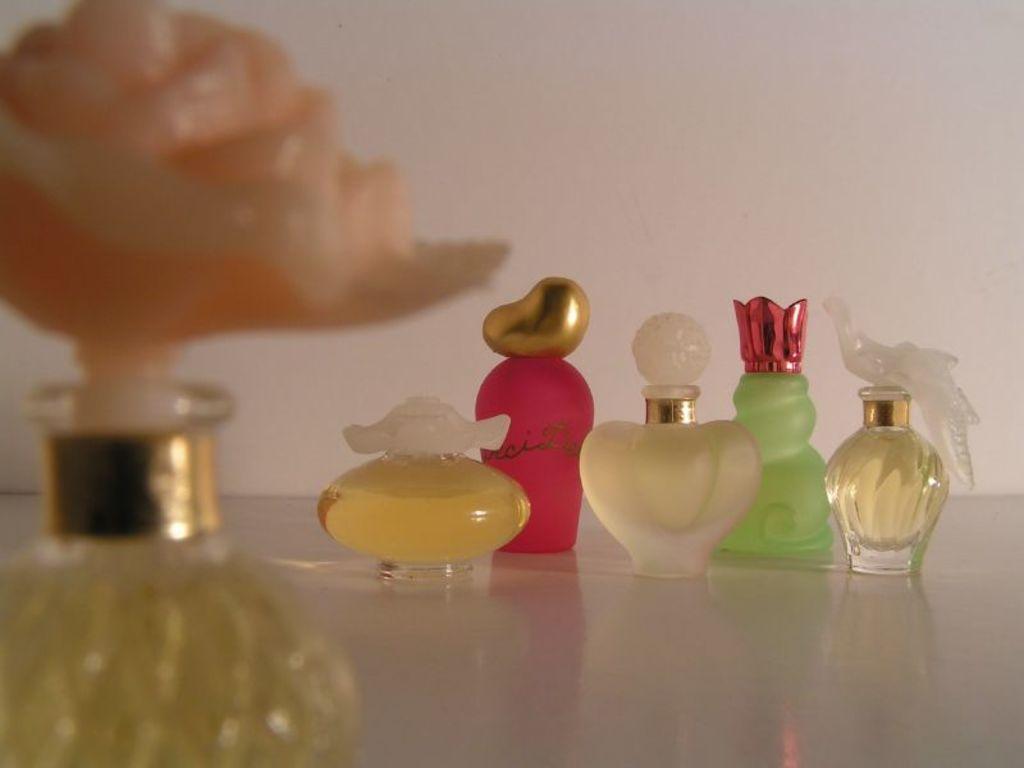Can you describe this image briefly? In the image we can see perfume bottles of different colors and shapes, kept on the white surface. We can see the wall, white in color.  